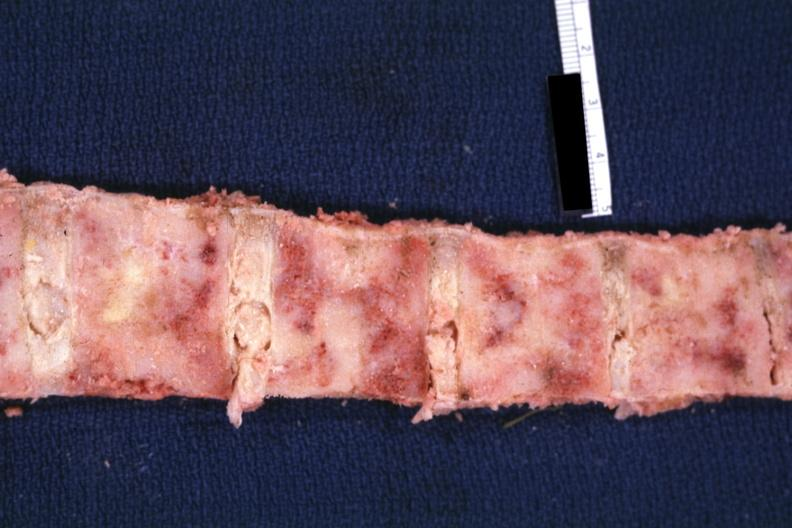does this image show bone nearly completely filled with tumor primary probably is lung?
Answer the question using a single word or phrase. Yes 